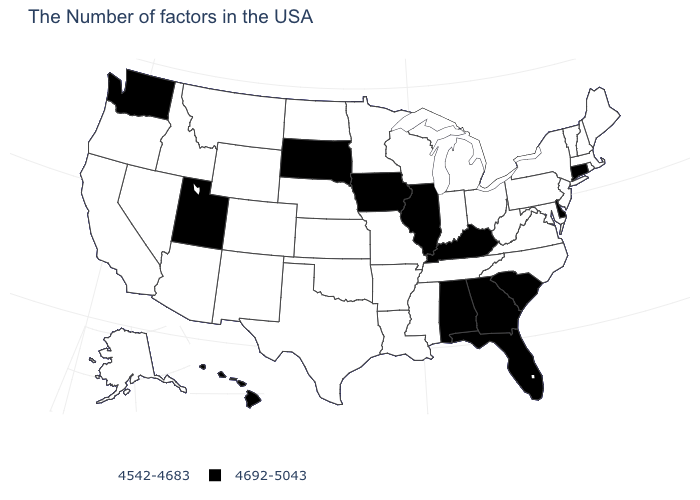Among the states that border Louisiana , which have the lowest value?
Keep it brief. Mississippi, Arkansas, Texas. How many symbols are there in the legend?
Keep it brief. 2. Does the first symbol in the legend represent the smallest category?
Be succinct. Yes. What is the value of Ohio?
Keep it brief. 4542-4683. What is the lowest value in the MidWest?
Concise answer only. 4542-4683. Among the states that border Arizona , which have the highest value?
Write a very short answer. Utah. Does Arizona have the lowest value in the USA?
Quick response, please. Yes. Among the states that border New Mexico , does Texas have the highest value?
Concise answer only. No. What is the lowest value in states that border North Carolina?
Keep it brief. 4542-4683. What is the value of Colorado?
Concise answer only. 4542-4683. Among the states that border Arizona , does New Mexico have the lowest value?
Give a very brief answer. Yes. Which states have the lowest value in the South?
Short answer required. Maryland, Virginia, North Carolina, West Virginia, Tennessee, Mississippi, Louisiana, Arkansas, Oklahoma, Texas. Name the states that have a value in the range 4542-4683?
Quick response, please. Maine, Massachusetts, Rhode Island, New Hampshire, Vermont, New York, New Jersey, Maryland, Pennsylvania, Virginia, North Carolina, West Virginia, Ohio, Michigan, Indiana, Tennessee, Wisconsin, Mississippi, Louisiana, Missouri, Arkansas, Minnesota, Kansas, Nebraska, Oklahoma, Texas, North Dakota, Wyoming, Colorado, New Mexico, Montana, Arizona, Idaho, Nevada, California, Oregon, Alaska. Does the map have missing data?
Quick response, please. No. What is the value of Minnesota?
Give a very brief answer. 4542-4683. 